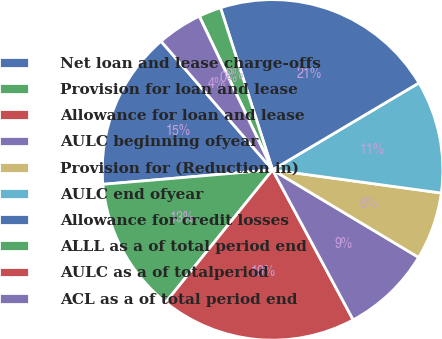<chart> <loc_0><loc_0><loc_500><loc_500><pie_chart><fcel>Net loan and lease charge-offs<fcel>Provision for loan and lease<fcel>Allowance for loan and lease<fcel>AULC beginning ofyear<fcel>Provision for (Reduction in)<fcel>AULC end ofyear<fcel>Allowance for credit losses<fcel>ALLL as a of total period end<fcel>AULC as a of totalperiod<fcel>ACL as a of total period end<nl><fcel>14.98%<fcel>12.84%<fcel>18.65%<fcel>8.56%<fcel>6.42%<fcel>10.7%<fcel>21.41%<fcel>2.14%<fcel>0.0%<fcel>4.28%<nl></chart> 